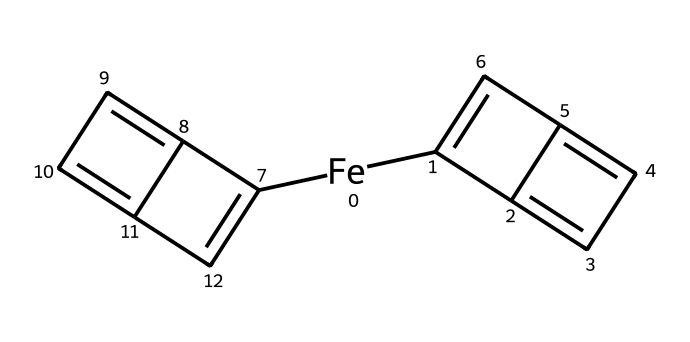What is the metal component of this structure? The structure contains an iron atom, which is the central metal atom in ferrocene, known for its organometallic characteristics.
Answer: iron How many cyclopentadienyl rings are present in ferrocene? The visual representation shows two cyclopentadienyl rings (five-membered carbon rings) bonded to the iron atom, characteristic of ferrocene's structure.
Answer: two What type of bonding is exhibited by the iron atom in this compound? The iron atom exhibits sandwich-type coordination with the two cyclopentadienyl rings, wherein the metal is coordinated between two π-acceptable ligands, demonstrating typical organometallic bonding.
Answer: sandwich What is the hybridization of the carbon atoms in the cyclopentadienyl rings? The carbon atoms in the cyclopentadienyl rings have sp2 hybridization, which allows for the formation of the delocalized π-electron system across each ring, contributing to the overall stability of the compound.
Answer: sp2 How does the structure of ferrocene contribute to its stability? Ferrocene's stability is due to the aromatic character of the cyclopentadienyl rings, which are stabilized by resonance, combined with the metal coordination that stabilizes the whole structure.
Answer: resonance What is the overall nomenclature class for the compound represented? This compound is classified as a metallocene due to its composition of a transition metal and cyclopentadienyl anions forming a stable organometallic complex.
Answer: metallocene 